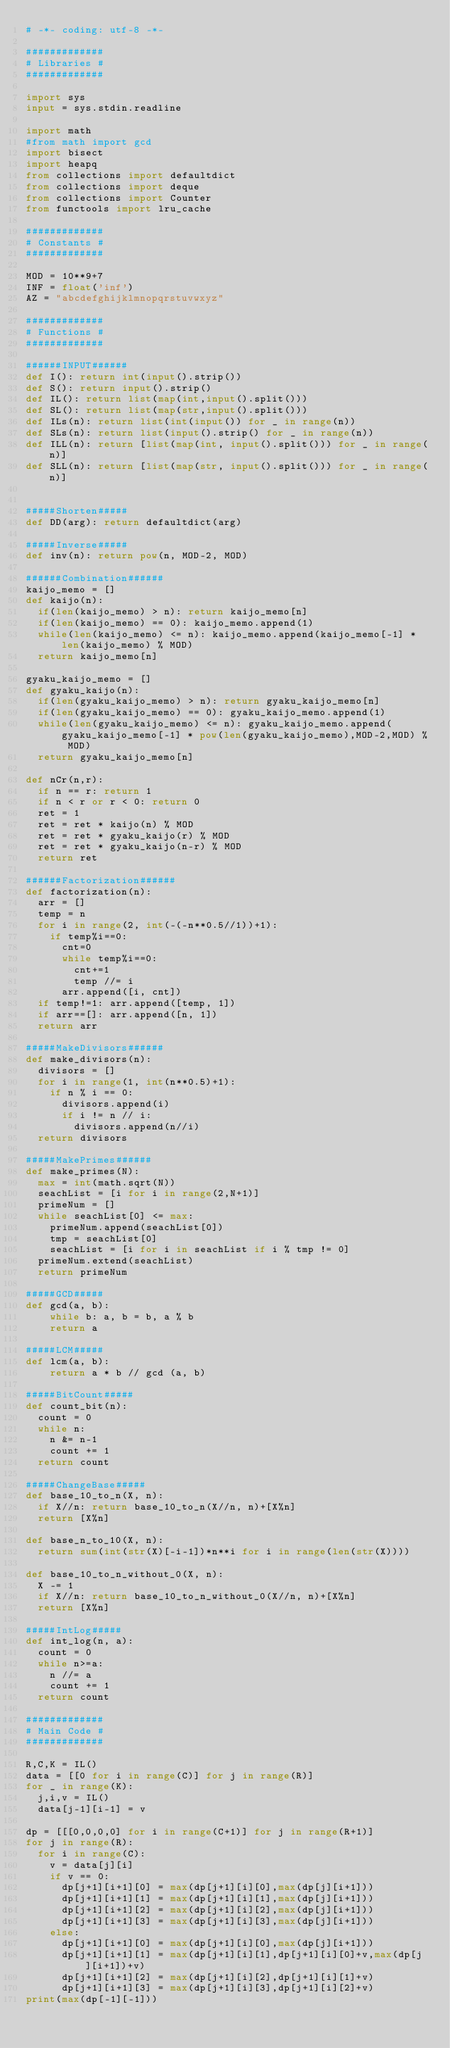<code> <loc_0><loc_0><loc_500><loc_500><_Python_># -*- coding: utf-8 -*-

#############
# Libraries #
#############

import sys
input = sys.stdin.readline

import math
#from math import gcd
import bisect
import heapq
from collections import defaultdict
from collections import deque
from collections import Counter
from functools import lru_cache

#############
# Constants #
#############

MOD = 10**9+7
INF = float('inf')
AZ = "abcdefghijklmnopqrstuvwxyz"

#############
# Functions #
#############

######INPUT######
def I(): return int(input().strip())
def S(): return input().strip()
def IL(): return list(map(int,input().split()))
def SL(): return list(map(str,input().split()))
def ILs(n): return list(int(input()) for _ in range(n))
def SLs(n): return list(input().strip() for _ in range(n))
def ILL(n): return [list(map(int, input().split())) for _ in range(n)]
def SLL(n): return [list(map(str, input().split())) for _ in range(n)]


#####Shorten#####
def DD(arg): return defaultdict(arg)

#####Inverse#####
def inv(n): return pow(n, MOD-2, MOD)

######Combination######
kaijo_memo = []
def kaijo(n):
  if(len(kaijo_memo) > n): return kaijo_memo[n]
  if(len(kaijo_memo) == 0): kaijo_memo.append(1)
  while(len(kaijo_memo) <= n): kaijo_memo.append(kaijo_memo[-1] * len(kaijo_memo) % MOD)
  return kaijo_memo[n]

gyaku_kaijo_memo = []
def gyaku_kaijo(n):
  if(len(gyaku_kaijo_memo) > n): return gyaku_kaijo_memo[n]
  if(len(gyaku_kaijo_memo) == 0): gyaku_kaijo_memo.append(1)
  while(len(gyaku_kaijo_memo) <= n): gyaku_kaijo_memo.append(gyaku_kaijo_memo[-1] * pow(len(gyaku_kaijo_memo),MOD-2,MOD) % MOD)
  return gyaku_kaijo_memo[n]

def nCr(n,r):
  if n == r: return 1
  if n < r or r < 0: return 0
  ret = 1
  ret = ret * kaijo(n) % MOD
  ret = ret * gyaku_kaijo(r) % MOD
  ret = ret * gyaku_kaijo(n-r) % MOD
  return ret

######Factorization######
def factorization(n):
  arr = []
  temp = n
  for i in range(2, int(-(-n**0.5//1))+1):
    if temp%i==0:
      cnt=0
      while temp%i==0: 
        cnt+=1 
        temp //= i
      arr.append([i, cnt])
  if temp!=1: arr.append([temp, 1])
  if arr==[]: arr.append([n, 1])
  return arr

#####MakeDivisors######
def make_divisors(n):
  divisors = []
  for i in range(1, int(n**0.5)+1):
    if n % i == 0:
      divisors.append(i)
      if i != n // i: 
        divisors.append(n//i)
  return divisors

#####MakePrimes######
def make_primes(N):
  max = int(math.sqrt(N))
  seachList = [i for i in range(2,N+1)]
  primeNum = []
  while seachList[0] <= max:
    primeNum.append(seachList[0])
    tmp = seachList[0]
    seachList = [i for i in seachList if i % tmp != 0]
  primeNum.extend(seachList)
  return primeNum

#####GCD#####
def gcd(a, b):
    while b: a, b = b, a % b
    return a

#####LCM#####
def lcm(a, b):
    return a * b // gcd (a, b)

#####BitCount#####
def count_bit(n):
  count = 0
  while n:
    n &= n-1
    count += 1
  return count

#####ChangeBase#####
def base_10_to_n(X, n):
  if X//n: return base_10_to_n(X//n, n)+[X%n]
  return [X%n]

def base_n_to_10(X, n):
  return sum(int(str(X)[-i-1])*n**i for i in range(len(str(X))))

def base_10_to_n_without_0(X, n):
  X -= 1
  if X//n: return base_10_to_n_without_0(X//n, n)+[X%n]
  return [X%n]

#####IntLog#####
def int_log(n, a):
  count = 0
  while n>=a:
    n //= a
    count += 1
  return count

#############
# Main Code #
#############

R,C,K = IL()
data = [[0 for i in range(C)] for j in range(R)]
for _ in range(K):
  j,i,v = IL()
  data[j-1][i-1] = v

dp = [[[0,0,0,0] for i in range(C+1)] for j in range(R+1)]
for j in range(R):
  for i in range(C):
    v = data[j][i] 
    if v == 0:
      dp[j+1][i+1][0] = max(dp[j+1][i][0],max(dp[j][i+1]))
      dp[j+1][i+1][1] = max(dp[j+1][i][1],max(dp[j][i+1]))
      dp[j+1][i+1][2] = max(dp[j+1][i][2],max(dp[j][i+1]))
      dp[j+1][i+1][3] = max(dp[j+1][i][3],max(dp[j][i+1]))
    else:
      dp[j+1][i+1][0] = max(dp[j+1][i][0],max(dp[j][i+1]))
      dp[j+1][i+1][1] = max(dp[j+1][i][1],dp[j+1][i][0]+v,max(dp[j][i+1])+v)
      dp[j+1][i+1][2] = max(dp[j+1][i][2],dp[j+1][i][1]+v)
      dp[j+1][i+1][3] = max(dp[j+1][i][3],dp[j+1][i][2]+v)
print(max(dp[-1][-1]))</code> 